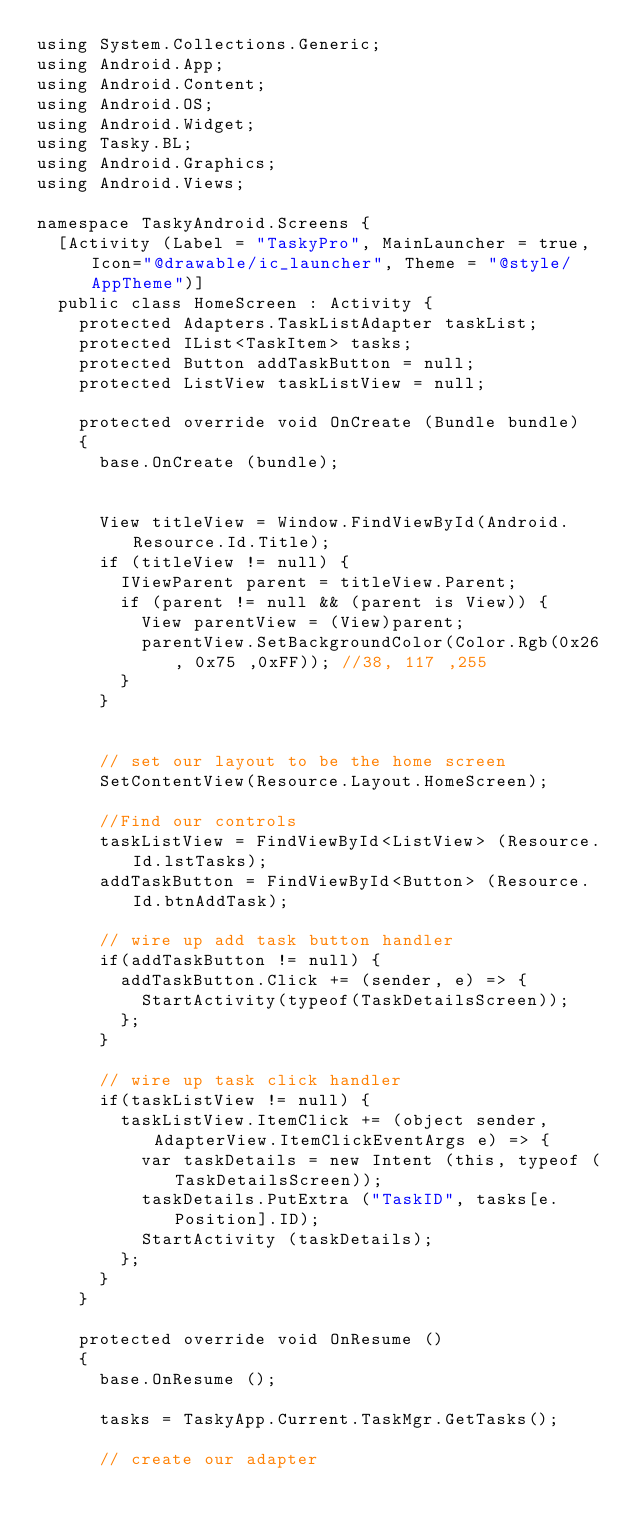<code> <loc_0><loc_0><loc_500><loc_500><_C#_>using System.Collections.Generic;
using Android.App;
using Android.Content;
using Android.OS;
using Android.Widget;
using Tasky.BL;
using Android.Graphics;
using Android.Views;

namespace TaskyAndroid.Screens {
	[Activity (Label = "TaskyPro", MainLauncher = true, Icon="@drawable/ic_launcher", Theme = "@style/AppTheme")]			
	public class HomeScreen : Activity {
		protected Adapters.TaskListAdapter taskList;
		protected IList<TaskItem> tasks;
		protected Button addTaskButton = null;
		protected ListView taskListView = null;
		
		protected override void OnCreate (Bundle bundle)
		{
			base.OnCreate (bundle);
			

			View titleView = Window.FindViewById(Android.Resource.Id.Title);
			if (titleView != null) {
			  IViewParent parent = titleView.Parent;
			  if (parent != null && (parent is View)) {
			    View parentView = (View)parent;
			    parentView.SetBackgroundColor(Color.Rgb(0x26, 0x75 ,0xFF)); //38, 117 ,255
			  }
			}


			// set our layout to be the home screen
			SetContentView(Resource.Layout.HomeScreen);

			//Find our controls
			taskListView = FindViewById<ListView> (Resource.Id.lstTasks);
			addTaskButton = FindViewById<Button> (Resource.Id.btnAddTask);

			// wire up add task button handler
			if(addTaskButton != null) {
				addTaskButton.Click += (sender, e) => {
					StartActivity(typeof(TaskDetailsScreen));
				};
			}
			
			// wire up task click handler
			if(taskListView != null) {
				taskListView.ItemClick += (object sender, AdapterView.ItemClickEventArgs e) => {
					var taskDetails = new Intent (this, typeof (TaskDetailsScreen));
					taskDetails.PutExtra ("TaskID", tasks[e.Position].ID);
					StartActivity (taskDetails);
				};
			}
		}
		
		protected override void OnResume ()
		{
			base.OnResume ();

			tasks = TaskyApp.Current.TaskMgr.GetTasks();
			
			// create our adapter</code> 